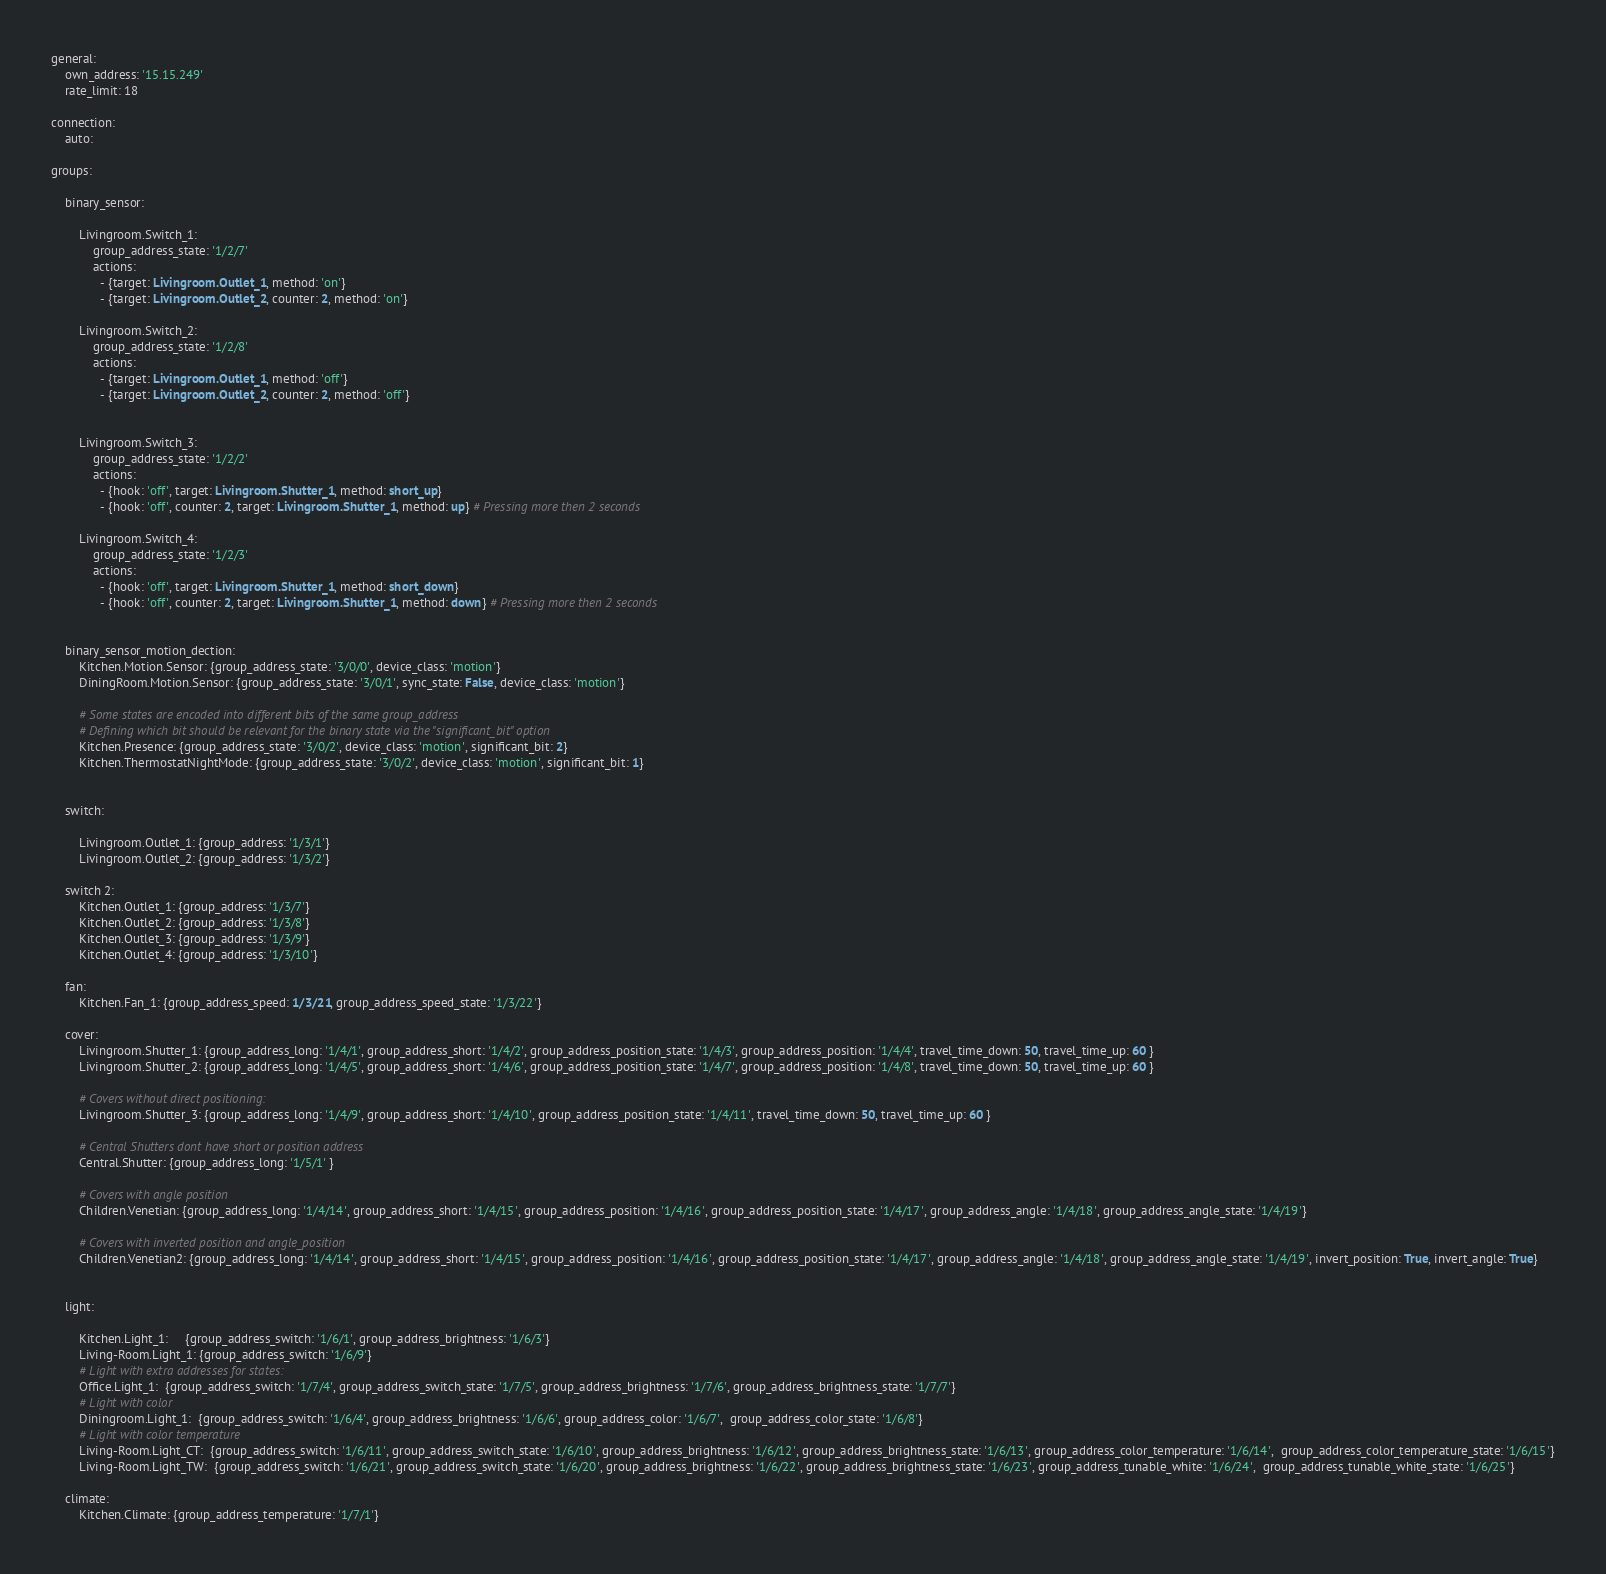Convert code to text. <code><loc_0><loc_0><loc_500><loc_500><_YAML_>
general:
    own_address: '15.15.249'
    rate_limit: 18

connection:
    auto:
    
groups:

    binary_sensor:

        Livingroom.Switch_1:
            group_address_state: '1/2/7'
            actions:
              - {target: Livingroom.Outlet_1, method: 'on'}
              - {target: Livingroom.Outlet_2, counter: 2, method: 'on'}

        Livingroom.Switch_2:
            group_address_state: '1/2/8'
            actions:
              - {target: Livingroom.Outlet_1, method: 'off'}
              - {target: Livingroom.Outlet_2, counter: 2, method: 'off'}


        Livingroom.Switch_3:
            group_address_state: '1/2/2'
            actions:
              - {hook: 'off', target: Livingroom.Shutter_1, method: short_up}
              - {hook: 'off', counter: 2, target: Livingroom.Shutter_1, method: up} # Pressing more then 2 seconds

        Livingroom.Switch_4:
            group_address_state: '1/2/3'
            actions:
              - {hook: 'off', target: Livingroom.Shutter_1, method: short_down}
              - {hook: 'off', counter: 2, target: Livingroom.Shutter_1, method: down} # Pressing more then 2 seconds


    binary_sensor_motion_dection:
        Kitchen.Motion.Sensor: {group_address_state: '3/0/0', device_class: 'motion'}
        DiningRoom.Motion.Sensor: {group_address_state: '3/0/1', sync_state: False, device_class: 'motion'}

        # Some states are encoded into different bits of the same group_address
        # Defining which bit should be relevant for the binary state via the "significant_bit" option
        Kitchen.Presence: {group_address_state: '3/0/2', device_class: 'motion', significant_bit: 2}
        Kitchen.ThermostatNightMode: {group_address_state: '3/0/2', device_class: 'motion', significant_bit: 1}


    switch:

        Livingroom.Outlet_1: {group_address: '1/3/1'}
        Livingroom.Outlet_2: {group_address: '1/3/2'}

    switch 2:
        Kitchen.Outlet_1: {group_address: '1/3/7'}
        Kitchen.Outlet_2: {group_address: '1/3/8'}
        Kitchen.Outlet_3: {group_address: '1/3/9'}
        Kitchen.Outlet_4: {group_address: '1/3/10'}

    fan:
        Kitchen.Fan_1: {group_address_speed: 1/3/21, group_address_speed_state: '1/3/22'}
        
    cover:
        Livingroom.Shutter_1: {group_address_long: '1/4/1', group_address_short: '1/4/2', group_address_position_state: '1/4/3', group_address_position: '1/4/4', travel_time_down: 50, travel_time_up: 60 }
        Livingroom.Shutter_2: {group_address_long: '1/4/5', group_address_short: '1/4/6', group_address_position_state: '1/4/7', group_address_position: '1/4/8', travel_time_down: 50, travel_time_up: 60 }

        # Covers without direct positioning:
        Livingroom.Shutter_3: {group_address_long: '1/4/9', group_address_short: '1/4/10', group_address_position_state: '1/4/11', travel_time_down: 50, travel_time_up: 60 }

        # Central Shutters dont have short or position address
        Central.Shutter: {group_address_long: '1/5/1' }

        # Covers with angle position
        Children.Venetian: {group_address_long: '1/4/14', group_address_short: '1/4/15', group_address_position: '1/4/16', group_address_position_state: '1/4/17', group_address_angle: '1/4/18', group_address_angle_state: '1/4/19'}

        # Covers with inverted position and angle_position
        Children.Venetian2: {group_address_long: '1/4/14', group_address_short: '1/4/15', group_address_position: '1/4/16', group_address_position_state: '1/4/17', group_address_angle: '1/4/18', group_address_angle_state: '1/4/19', invert_position: True, invert_angle: True}


    light:

        Kitchen.Light_1:     {group_address_switch: '1/6/1', group_address_brightness: '1/6/3'}
        Living-Room.Light_1: {group_address_switch: '1/6/9'}
        # Light with extra addresses for states:
        Office.Light_1:  {group_address_switch: '1/7/4', group_address_switch_state: '1/7/5', group_address_brightness: '1/7/6', group_address_brightness_state: '1/7/7'}
        # Light with color
        Diningroom.Light_1:  {group_address_switch: '1/6/4', group_address_brightness: '1/6/6', group_address_color: '1/6/7',  group_address_color_state: '1/6/8'}
        # Light with color temperature
        Living-Room.Light_CT:  {group_address_switch: '1/6/11', group_address_switch_state: '1/6/10', group_address_brightness: '1/6/12', group_address_brightness_state: '1/6/13', group_address_color_temperature: '1/6/14',  group_address_color_temperature_state: '1/6/15'}
        Living-Room.Light_TW:  {group_address_switch: '1/6/21', group_address_switch_state: '1/6/20', group_address_brightness: '1/6/22', group_address_brightness_state: '1/6/23', group_address_tunable_white: '1/6/24',  group_address_tunable_white_state: '1/6/25'}

    climate:
        Kitchen.Climate: {group_address_temperature: '1/7/1'}</code> 